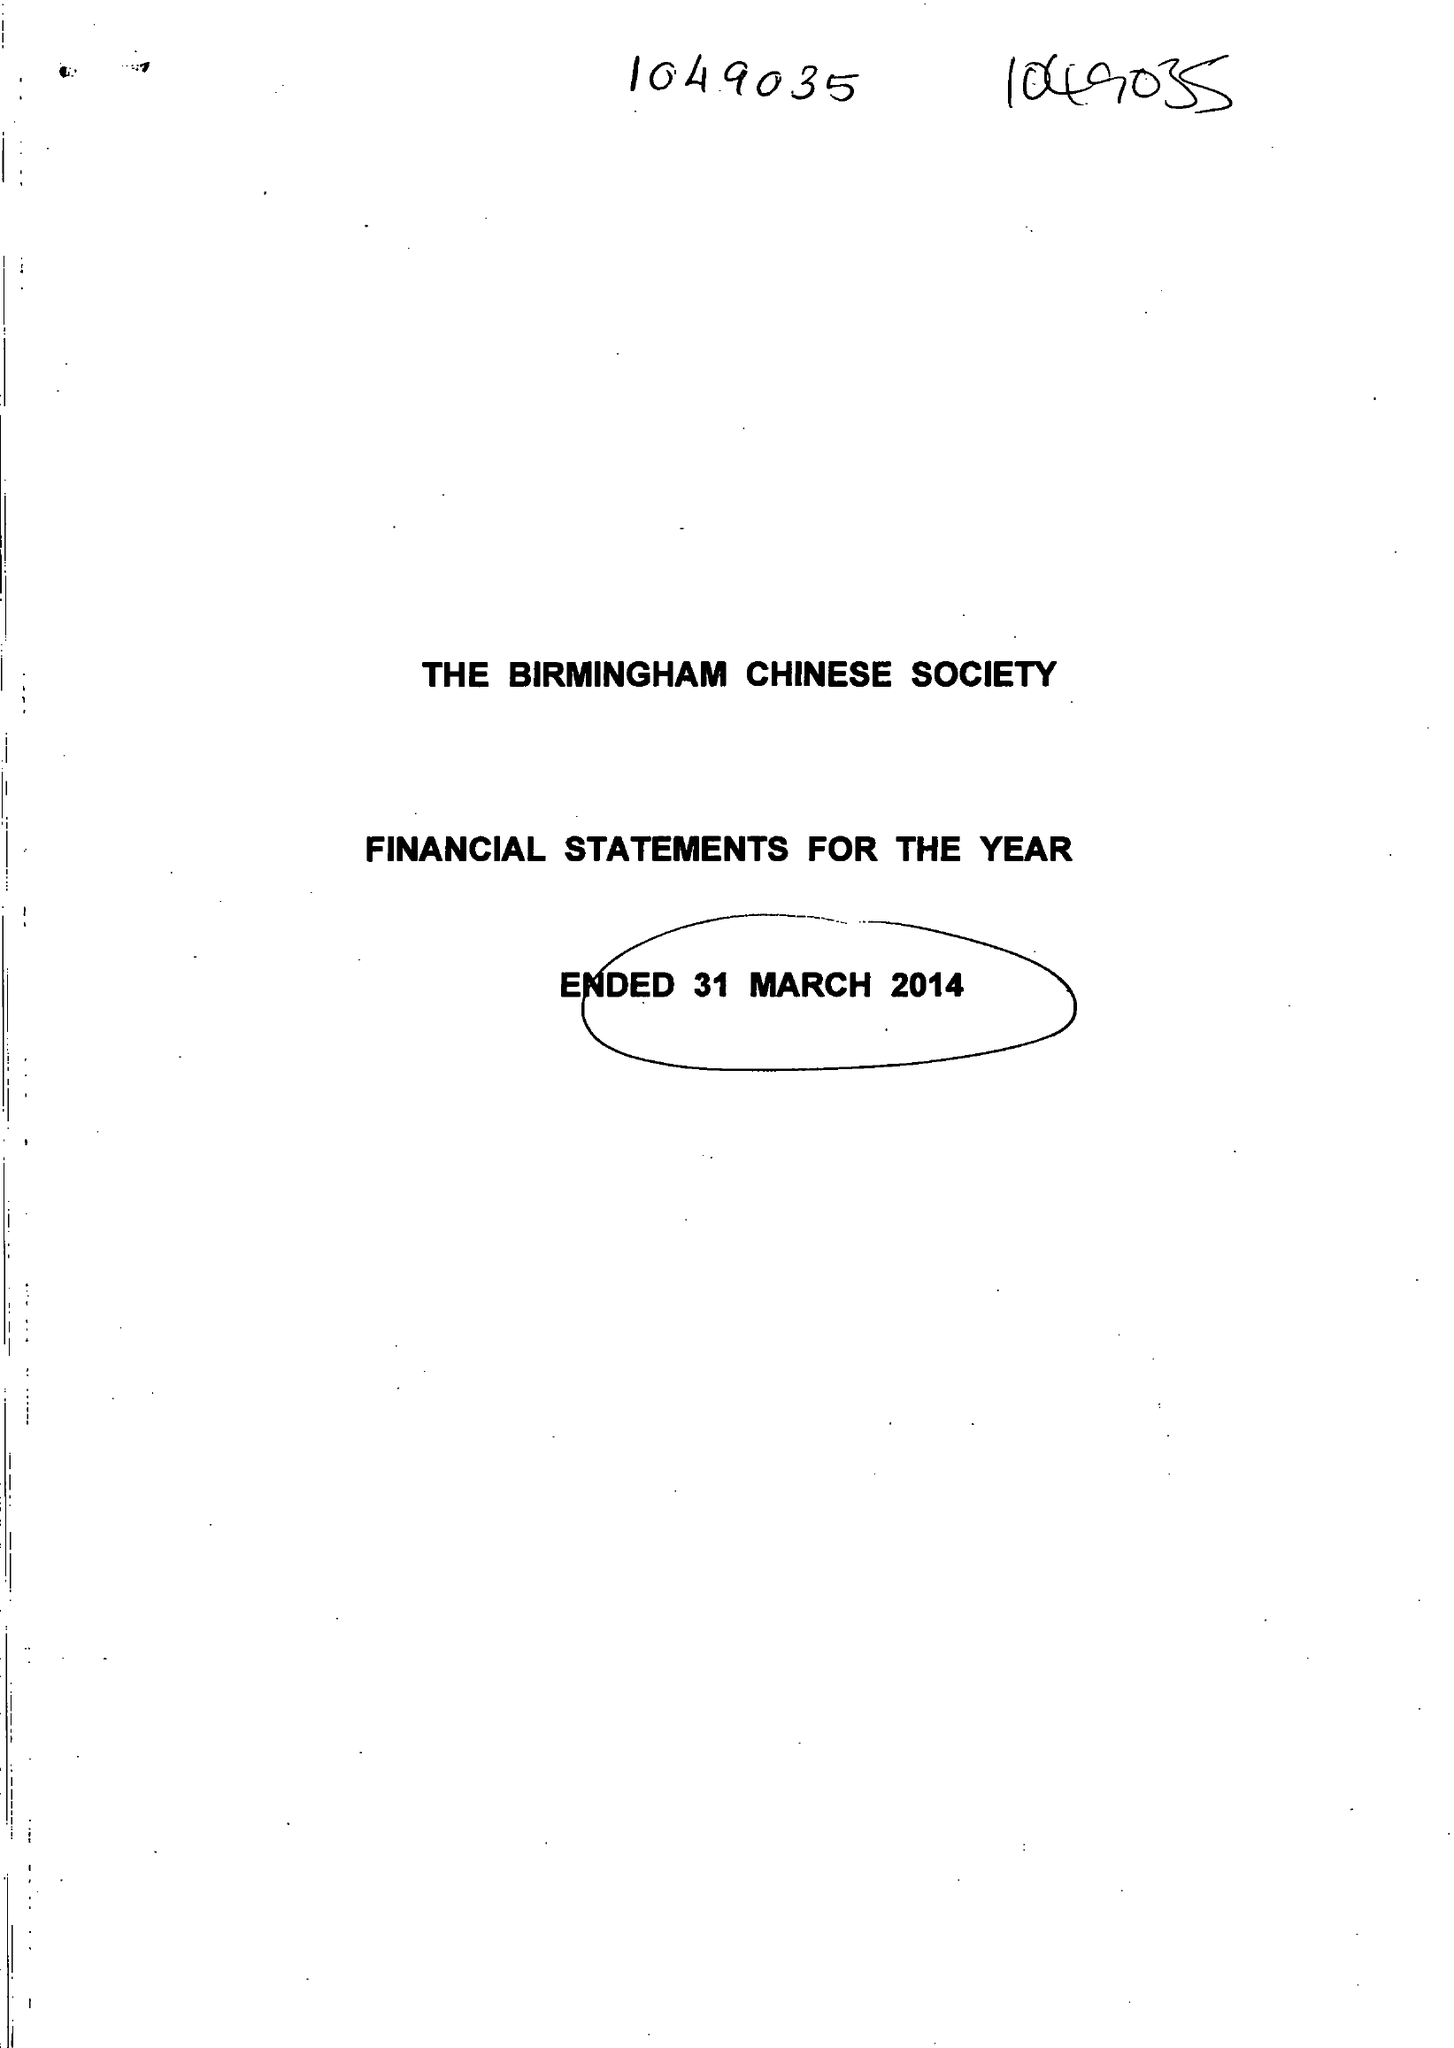What is the value for the charity_name?
Answer the question using a single word or phrase. The Birmingham Chinese Society 